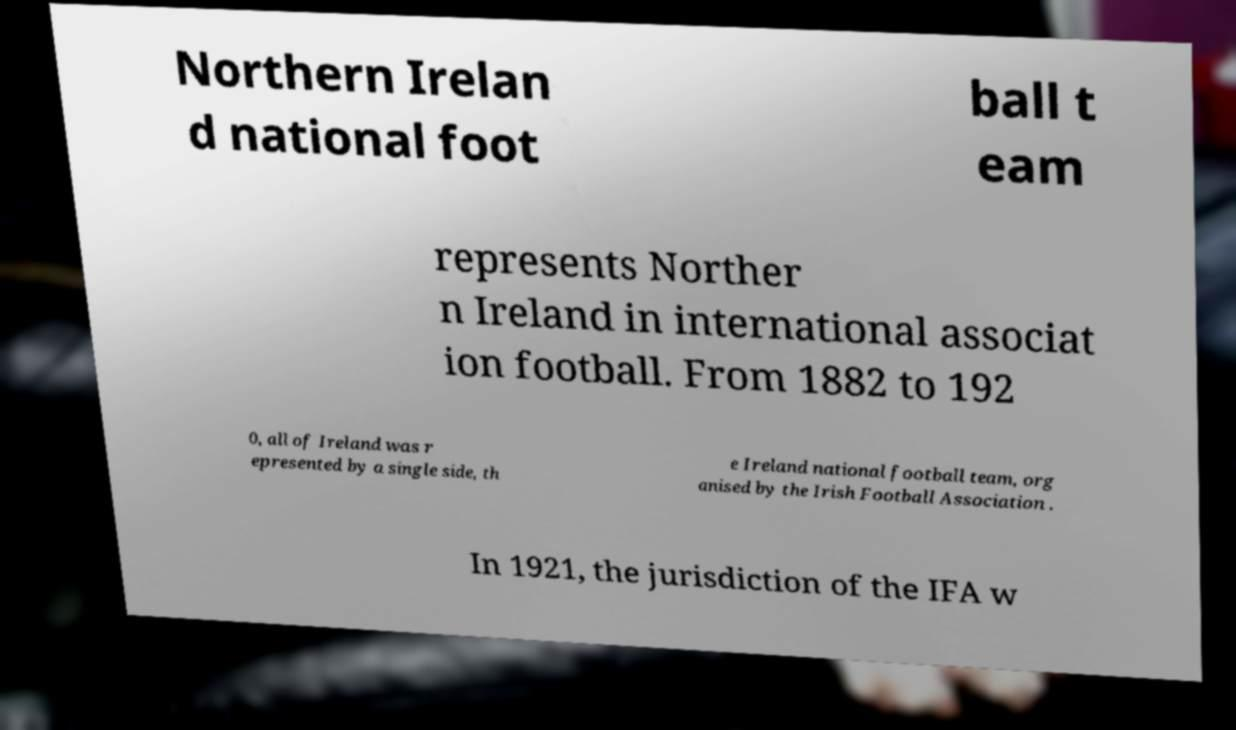For documentation purposes, I need the text within this image transcribed. Could you provide that? Northern Irelan d national foot ball t eam represents Norther n Ireland in international associat ion football. From 1882 to 192 0, all of Ireland was r epresented by a single side, th e Ireland national football team, org anised by the Irish Football Association . In 1921, the jurisdiction of the IFA w 